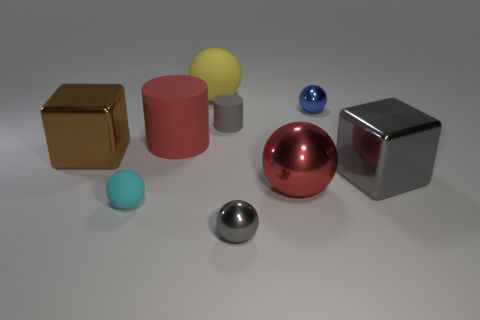There is a metallic cube left of the small gray metal object; is there a small thing in front of it?
Your response must be concise. Yes. Are there an equal number of big rubber balls in front of the small cyan rubber thing and small shiny cylinders?
Provide a succinct answer. Yes. What number of other things are the same size as the gray cylinder?
Offer a terse response. 3. Do the ball on the left side of the large cylinder and the small gray object that is behind the tiny cyan ball have the same material?
Provide a short and direct response. Yes. There is a shiny ball that is on the right side of the big red object right of the gray cylinder; what is its size?
Provide a short and direct response. Small. Are there any other big matte cylinders of the same color as the big cylinder?
Offer a very short reply. No. There is a small matte object right of the big rubber sphere; does it have the same color as the tiny metallic ball that is in front of the blue metal thing?
Provide a short and direct response. Yes. What is the shape of the big brown metal thing?
Your answer should be compact. Cube. What number of gray metal objects are to the right of the big red matte cylinder?
Offer a very short reply. 2. What number of small gray objects have the same material as the big brown block?
Give a very brief answer. 1. 